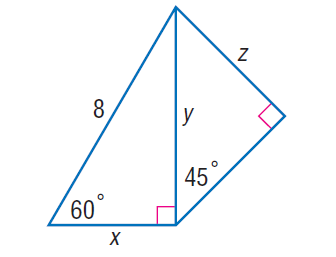Question: Find z.
Choices:
A. 2 \sqrt { 6 }
B. 6
C. 4 \sqrt { 3 }
D. 12
Answer with the letter. Answer: A Question: Find y.
Choices:
A. 4
B. 4 \sqrt { 3 }
C. 8
D. 8 \sqrt { 3 }
Answer with the letter. Answer: B Question: Find x.
Choices:
A. 2 \sqrt { 3 }
B. 4
C. 4 \sqrt { 3 }
D. 8
Answer with the letter. Answer: B 